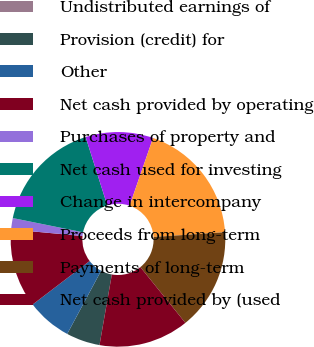<chart> <loc_0><loc_0><loc_500><loc_500><pie_chart><fcel>Undistributed earnings of<fcel>Provision (credit) for<fcel>Other<fcel>Net cash provided by operating<fcel>Purchases of property and<fcel>Net cash used for investing<fcel>Change in intercompany<fcel>Proceeds from long-term<fcel>Payments of long-term<fcel>Net cash provided by (used<nl><fcel>0.0%<fcel>5.09%<fcel>6.78%<fcel>11.86%<fcel>1.7%<fcel>16.95%<fcel>10.17%<fcel>18.64%<fcel>15.25%<fcel>13.56%<nl></chart> 